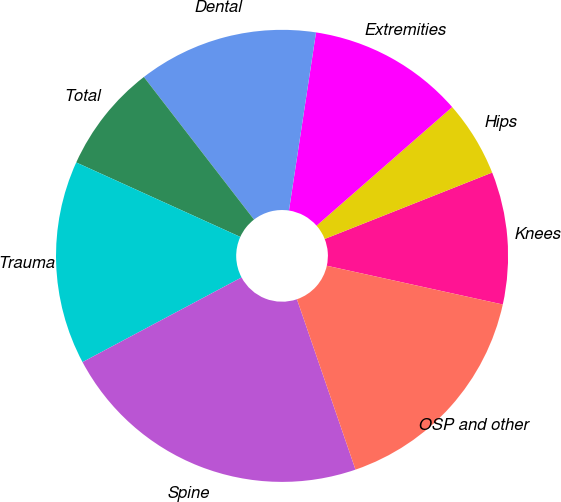Convert chart to OTSL. <chart><loc_0><loc_0><loc_500><loc_500><pie_chart><fcel>Knees<fcel>Hips<fcel>Extremities<fcel>Dental<fcel>Total<fcel>Trauma<fcel>Spine<fcel>OSP and other<nl><fcel>9.46%<fcel>5.43%<fcel>11.16%<fcel>12.87%<fcel>7.75%<fcel>14.57%<fcel>22.48%<fcel>16.28%<nl></chart> 